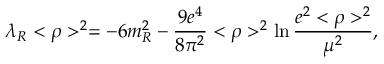<formula> <loc_0><loc_0><loc_500><loc_500>\lambda _ { R } < \rho > ^ { 2 } = - 6 m _ { R } ^ { 2 } - \frac { 9 e ^ { 4 } } { 8 \pi ^ { 2 } } < \rho > ^ { 2 } \ln \frac { e ^ { 2 } < \rho > ^ { 2 } } { \mu ^ { 2 } } ,</formula> 